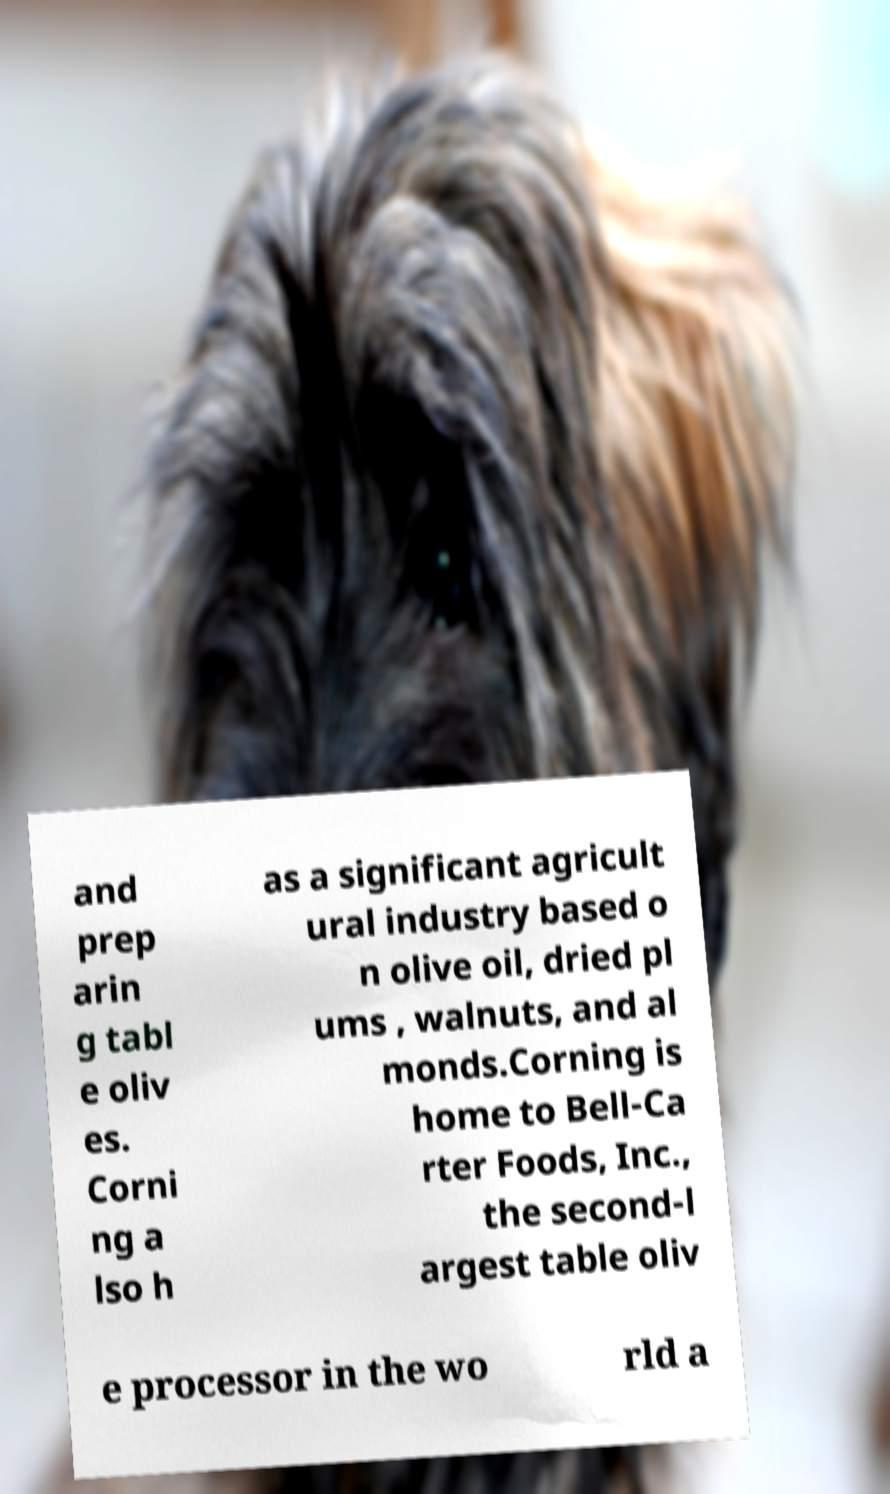What messages or text are displayed in this image? I need them in a readable, typed format. and prep arin g tabl e oliv es. Corni ng a lso h as a significant agricult ural industry based o n olive oil, dried pl ums , walnuts, and al monds.Corning is home to Bell-Ca rter Foods, Inc., the second-l argest table oliv e processor in the wo rld a 